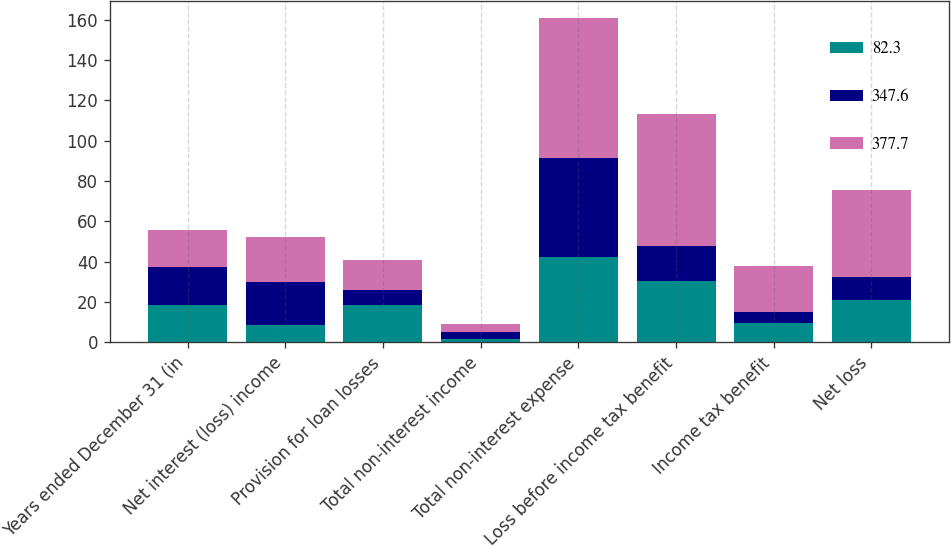Convert chart. <chart><loc_0><loc_0><loc_500><loc_500><stacked_bar_chart><ecel><fcel>Years ended December 31 (in<fcel>Net interest (loss) income<fcel>Provision for loan losses<fcel>Total non-interest income<fcel>Total non-interest expense<fcel>Loss before income tax benefit<fcel>Income tax benefit<fcel>Net loss<nl><fcel>82.3<fcel>18.6<fcel>8.7<fcel>18.6<fcel>1.8<fcel>42.1<fcel>30.4<fcel>9.5<fcel>20.9<nl><fcel>347.6<fcel>18.6<fcel>21.2<fcel>7.6<fcel>3.2<fcel>49.3<fcel>17.3<fcel>5.6<fcel>11.7<nl><fcel>377.7<fcel>18.6<fcel>22.4<fcel>14.5<fcel>4<fcel>69.6<fcel>65.7<fcel>22.9<fcel>42.8<nl></chart> 